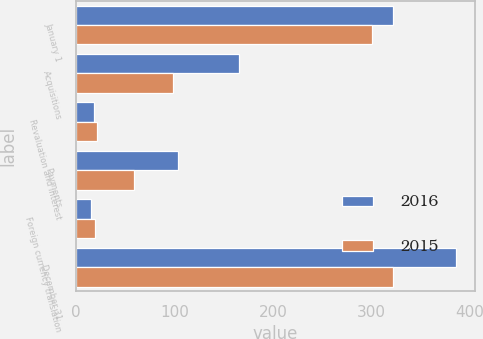Convert chart to OTSL. <chart><loc_0><loc_0><loc_500><loc_500><stacked_bar_chart><ecel><fcel>January 1<fcel>Acquisitions<fcel>Revaluation and interest<fcel>Payments<fcel>Foreign currency translation<fcel>December 31<nl><fcel>2016<fcel>322<fcel>165.3<fcel>18<fcel>103.7<fcel>15.5<fcel>386.1<nl><fcel>2015<fcel>300.7<fcel>98.9<fcel>21.8<fcel>58.6<fcel>19.4<fcel>322<nl></chart> 